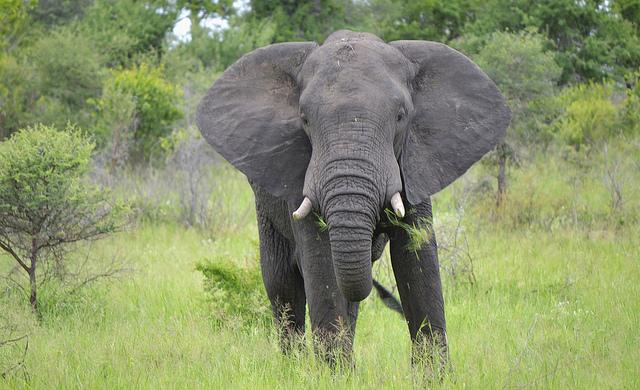How many elephants in the scene?
Short answer required. 1. Have the elephant's ears been cut off?
Keep it brief. No. Could this animal be a juvenile?
Keep it brief. No. Is this elephant gray?
Keep it brief. Yes. Does the elephant have both tusks?
Short answer required. Yes. Is the grass green?
Concise answer only. Yes. How many elephants are there?
Write a very short answer. 1. What is he eating?
Short answer required. Grass. Is the elephant walking?
Short answer required. Yes. Does the elephant have tusks?
Give a very brief answer. Yes. 